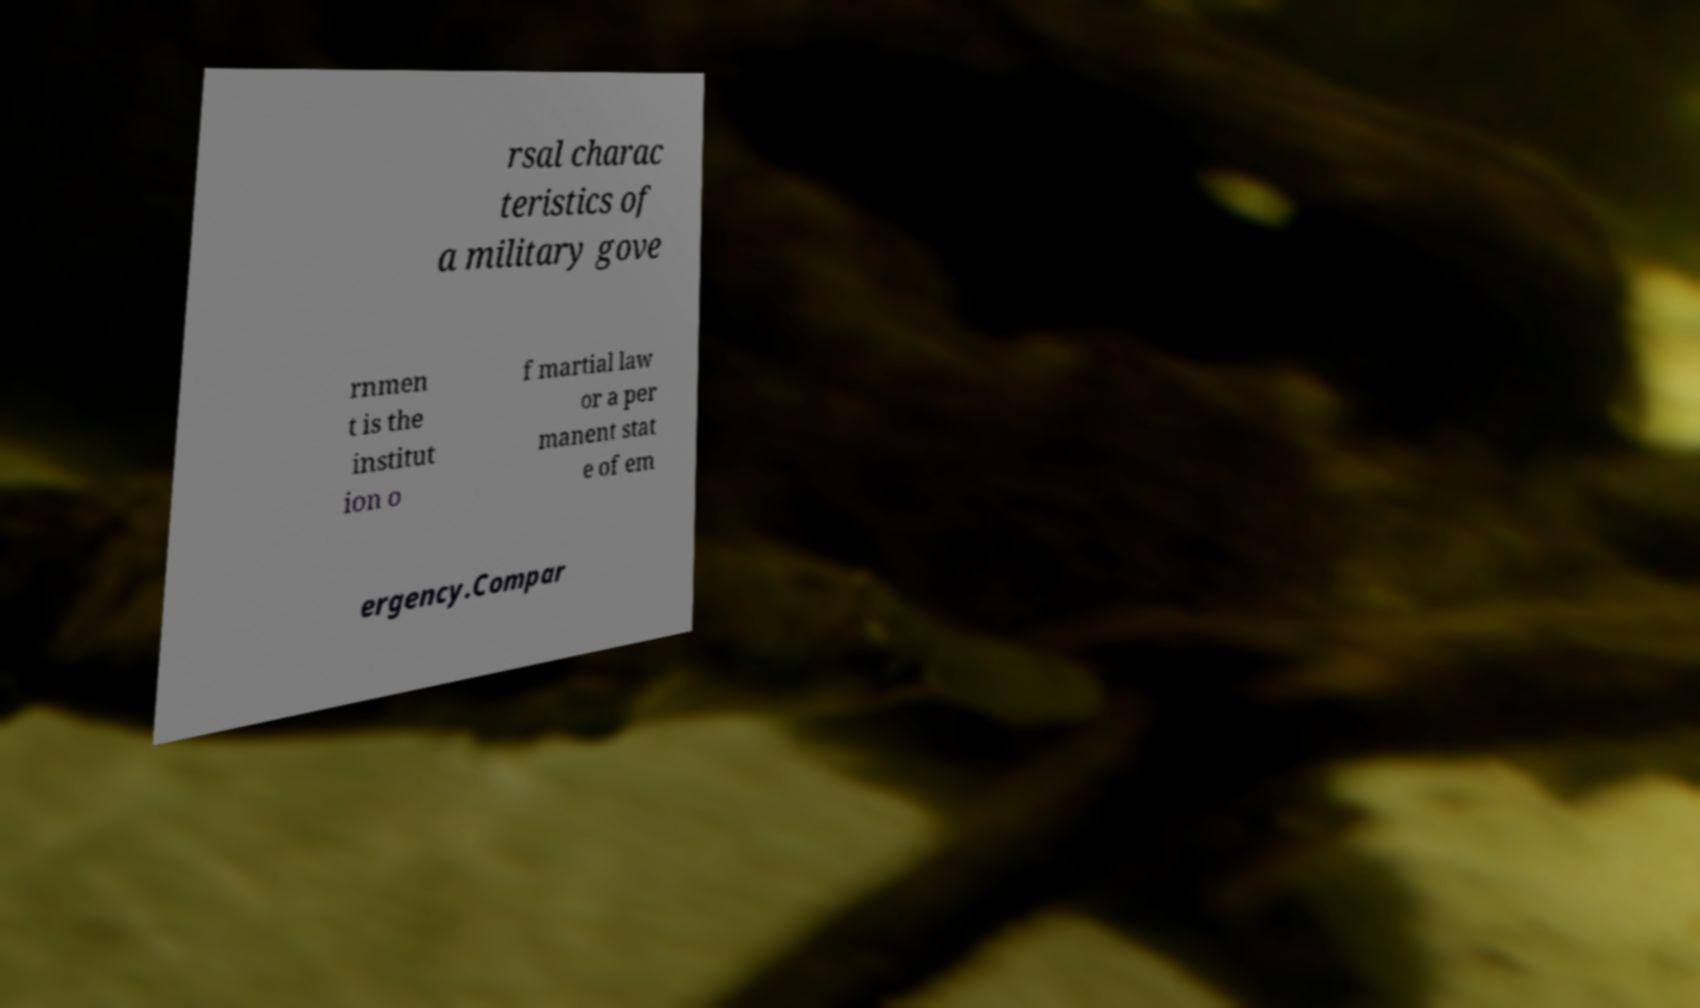What messages or text are displayed in this image? I need them in a readable, typed format. rsal charac teristics of a military gove rnmen t is the institut ion o f martial law or a per manent stat e of em ergency.Compar 